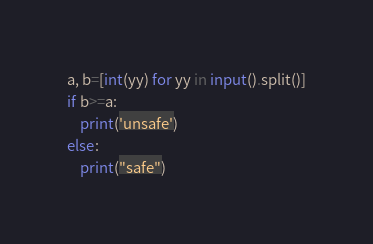<code> <loc_0><loc_0><loc_500><loc_500><_Python_>a, b=[int(yy) for yy in input().split()]
if b>=a:
	print('unsafe')
else:
	print("safe")
</code> 